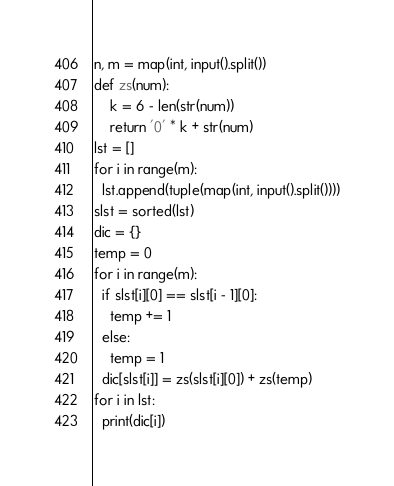Convert code to text. <code><loc_0><loc_0><loc_500><loc_500><_Python_>n, m = map(int, input().split())
def zs(num):
    k = 6 - len(str(num))
    return '0' * k + str(num)
lst = []
for i in range(m):
  lst.append(tuple(map(int, input().split())))
slst = sorted(lst)
dic = {}
temp = 0
for i in range(m):
  if slst[i][0] == slst[i - 1][0]:
    temp += 1
  else:
    temp = 1
  dic[slst[i]] = zs(slst[i][0]) + zs(temp)
for i in lst:
  print(dic[i])</code> 